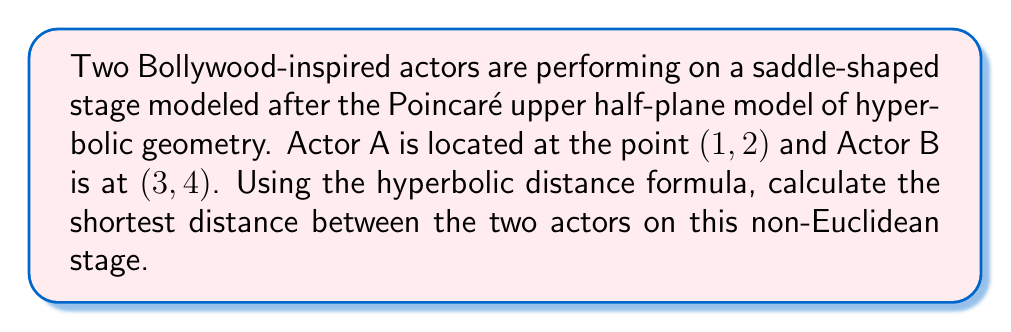What is the answer to this math problem? To solve this problem, we'll use the hyperbolic distance formula in the Poincaré upper half-plane model:

1) The hyperbolic distance $d$ between two points $(x_1, y_1)$ and $(x_2, y_2)$ is given by:

   $$d = \text{arcosh}\left(1 + \frac{(x_2 - x_1)^2 + (y_2 - y_1)^2}{2y_1y_2}\right)$$

   Where arcosh is the inverse hyperbolic cosine function.

2) We have:
   Actor A: $(x_1, y_1) = (1, 2)$
   Actor B: $(x_2, y_2) = (3, 4)$

3) Let's substitute these values into our formula:

   $$d = \text{arcosh}\left(1 + \frac{(3 - 1)^2 + (4 - 2)^2}{2 \cdot 2 \cdot 4}\right)$$

4) Simplify inside the parentheses:

   $$d = \text{arcosh}\left(1 + \frac{4 + 4}{16}\right) = \text{arcosh}\left(1 + \frac{8}{16}\right) = \text{arcosh}\left(1 + \frac{1}{2}\right)$$

5) Simplify further:

   $$d = \text{arcosh}\left(\frac{3}{2}\right)$$

6) This is our final answer in its simplest form.
Answer: $\text{arcosh}\left(\frac{3}{2}\right)$ 